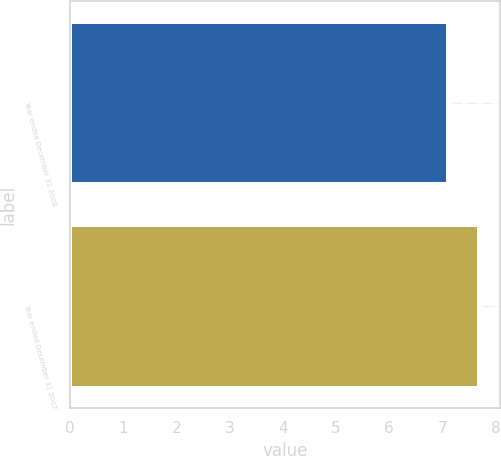<chart> <loc_0><loc_0><loc_500><loc_500><bar_chart><fcel>Year ended December 31 2008<fcel>Year ended December 31 2007<nl><fcel>7.1<fcel>7.7<nl></chart> 